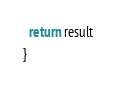<code> <loc_0><loc_0><loc_500><loc_500><_TypeScript_>
  return result
}
</code> 